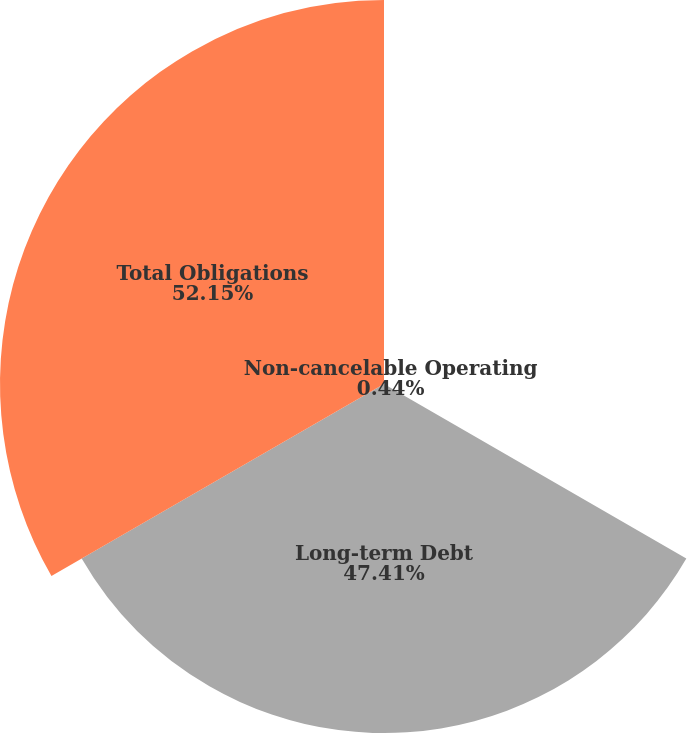<chart> <loc_0><loc_0><loc_500><loc_500><pie_chart><fcel>Non-cancelable Operating<fcel>Long-term Debt<fcel>Total Obligations<nl><fcel>0.44%<fcel>47.41%<fcel>52.15%<nl></chart> 